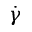<formula> <loc_0><loc_0><loc_500><loc_500>\dot { \gamma }</formula> 